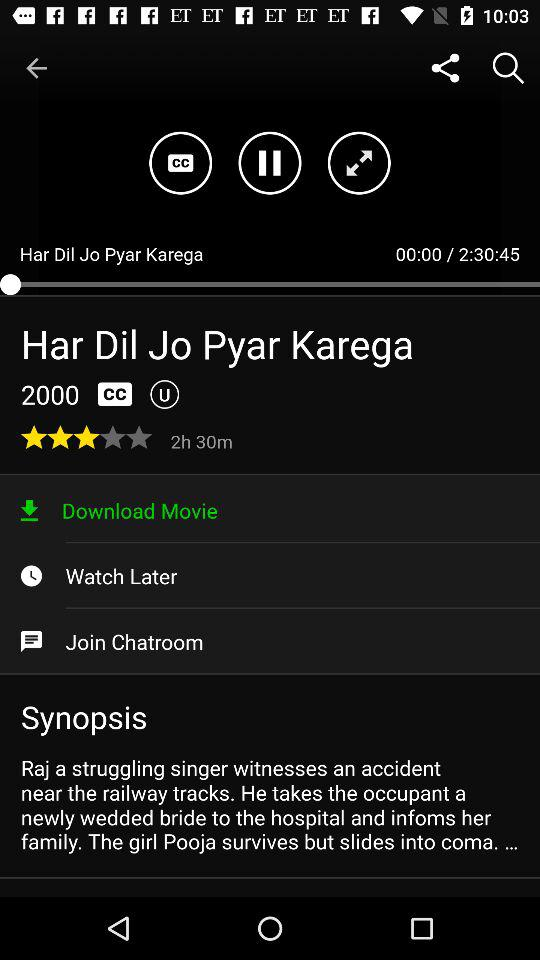What is the title of the movie? The title of the movie is "Har Dil Jo Pyar Karega". 